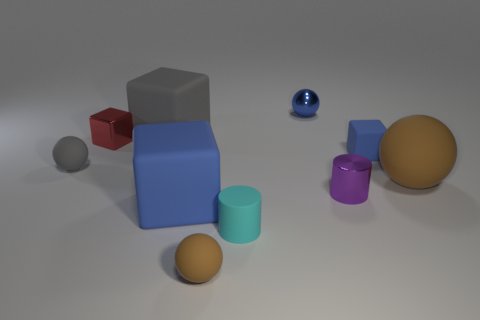Subtract all tiny metal cubes. How many cubes are left? 3 Subtract all brown blocks. Subtract all brown balls. How many blocks are left? 4 Subtract all balls. How many objects are left? 6 Add 7 small blue spheres. How many small blue spheres exist? 8 Subtract 0 purple cubes. How many objects are left? 10 Subtract all small blue objects. Subtract all big yellow blocks. How many objects are left? 8 Add 2 big gray rubber blocks. How many big gray rubber blocks are left? 3 